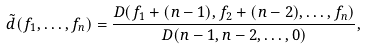<formula> <loc_0><loc_0><loc_500><loc_500>\tilde { d } ( f _ { 1 } , \dots , f _ { n } ) = \frac { D ( f _ { 1 } + ( n - 1 ) , f _ { 2 } + ( n - 2 ) , \dots , f _ { n } ) } { D ( n - 1 , n - 2 , \dots , 0 ) } , \label s { d U n }</formula> 